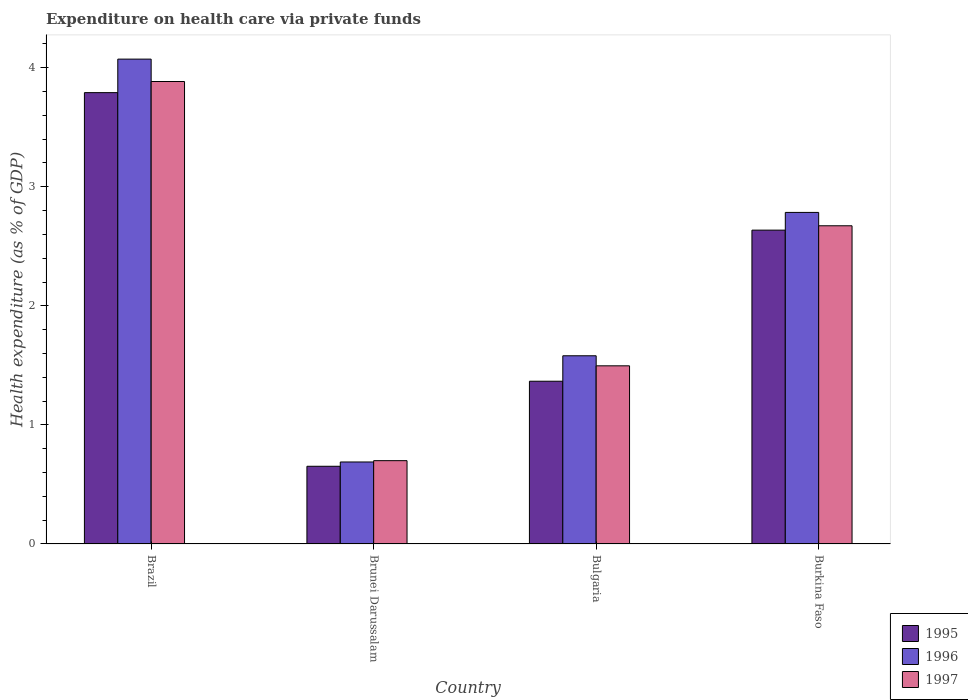How many bars are there on the 1st tick from the left?
Give a very brief answer. 3. In how many cases, is the number of bars for a given country not equal to the number of legend labels?
Ensure brevity in your answer.  0. What is the expenditure made on health care in 1995 in Brazil?
Your answer should be very brief. 3.79. Across all countries, what is the maximum expenditure made on health care in 1997?
Your response must be concise. 3.88. Across all countries, what is the minimum expenditure made on health care in 1996?
Ensure brevity in your answer.  0.69. In which country was the expenditure made on health care in 1996 minimum?
Your response must be concise. Brunei Darussalam. What is the total expenditure made on health care in 1995 in the graph?
Provide a short and direct response. 8.45. What is the difference between the expenditure made on health care in 1996 in Brunei Darussalam and that in Burkina Faso?
Make the answer very short. -2.1. What is the difference between the expenditure made on health care in 1997 in Burkina Faso and the expenditure made on health care in 1996 in Brunei Darussalam?
Ensure brevity in your answer.  1.98. What is the average expenditure made on health care in 1996 per country?
Make the answer very short. 2.28. What is the difference between the expenditure made on health care of/in 1997 and expenditure made on health care of/in 1996 in Bulgaria?
Offer a very short reply. -0.08. What is the ratio of the expenditure made on health care in 1997 in Brunei Darussalam to that in Burkina Faso?
Your response must be concise. 0.26. Is the expenditure made on health care in 1995 in Brazil less than that in Bulgaria?
Your answer should be very brief. No. Is the difference between the expenditure made on health care in 1997 in Brazil and Bulgaria greater than the difference between the expenditure made on health care in 1996 in Brazil and Bulgaria?
Offer a terse response. No. What is the difference between the highest and the second highest expenditure made on health care in 1996?
Ensure brevity in your answer.  -1.2. What is the difference between the highest and the lowest expenditure made on health care in 1995?
Offer a very short reply. 3.14. In how many countries, is the expenditure made on health care in 1996 greater than the average expenditure made on health care in 1996 taken over all countries?
Ensure brevity in your answer.  2. Is the sum of the expenditure made on health care in 1996 in Brunei Darussalam and Burkina Faso greater than the maximum expenditure made on health care in 1995 across all countries?
Ensure brevity in your answer.  No. How many bars are there?
Your response must be concise. 12. Are all the bars in the graph horizontal?
Ensure brevity in your answer.  No. How many countries are there in the graph?
Your response must be concise. 4. What is the difference between two consecutive major ticks on the Y-axis?
Make the answer very short. 1. What is the title of the graph?
Make the answer very short. Expenditure on health care via private funds. What is the label or title of the X-axis?
Your response must be concise. Country. What is the label or title of the Y-axis?
Keep it short and to the point. Health expenditure (as % of GDP). What is the Health expenditure (as % of GDP) of 1995 in Brazil?
Keep it short and to the point. 3.79. What is the Health expenditure (as % of GDP) of 1996 in Brazil?
Provide a succinct answer. 4.07. What is the Health expenditure (as % of GDP) in 1997 in Brazil?
Provide a short and direct response. 3.88. What is the Health expenditure (as % of GDP) of 1995 in Brunei Darussalam?
Provide a short and direct response. 0.65. What is the Health expenditure (as % of GDP) of 1996 in Brunei Darussalam?
Provide a succinct answer. 0.69. What is the Health expenditure (as % of GDP) in 1997 in Brunei Darussalam?
Ensure brevity in your answer.  0.7. What is the Health expenditure (as % of GDP) in 1995 in Bulgaria?
Give a very brief answer. 1.37. What is the Health expenditure (as % of GDP) in 1996 in Bulgaria?
Provide a short and direct response. 1.58. What is the Health expenditure (as % of GDP) of 1997 in Bulgaria?
Your answer should be very brief. 1.5. What is the Health expenditure (as % of GDP) of 1995 in Burkina Faso?
Offer a terse response. 2.64. What is the Health expenditure (as % of GDP) in 1996 in Burkina Faso?
Make the answer very short. 2.78. What is the Health expenditure (as % of GDP) in 1997 in Burkina Faso?
Make the answer very short. 2.67. Across all countries, what is the maximum Health expenditure (as % of GDP) in 1995?
Your answer should be compact. 3.79. Across all countries, what is the maximum Health expenditure (as % of GDP) in 1996?
Provide a short and direct response. 4.07. Across all countries, what is the maximum Health expenditure (as % of GDP) of 1997?
Offer a terse response. 3.88. Across all countries, what is the minimum Health expenditure (as % of GDP) in 1995?
Provide a succinct answer. 0.65. Across all countries, what is the minimum Health expenditure (as % of GDP) of 1996?
Make the answer very short. 0.69. Across all countries, what is the minimum Health expenditure (as % of GDP) in 1997?
Your answer should be compact. 0.7. What is the total Health expenditure (as % of GDP) of 1995 in the graph?
Provide a short and direct response. 8.45. What is the total Health expenditure (as % of GDP) in 1996 in the graph?
Make the answer very short. 9.13. What is the total Health expenditure (as % of GDP) in 1997 in the graph?
Give a very brief answer. 8.75. What is the difference between the Health expenditure (as % of GDP) in 1995 in Brazil and that in Brunei Darussalam?
Keep it short and to the point. 3.14. What is the difference between the Health expenditure (as % of GDP) of 1996 in Brazil and that in Brunei Darussalam?
Keep it short and to the point. 3.38. What is the difference between the Health expenditure (as % of GDP) of 1997 in Brazil and that in Brunei Darussalam?
Your answer should be very brief. 3.18. What is the difference between the Health expenditure (as % of GDP) of 1995 in Brazil and that in Bulgaria?
Offer a terse response. 2.42. What is the difference between the Health expenditure (as % of GDP) of 1996 in Brazil and that in Bulgaria?
Ensure brevity in your answer.  2.49. What is the difference between the Health expenditure (as % of GDP) of 1997 in Brazil and that in Bulgaria?
Keep it short and to the point. 2.39. What is the difference between the Health expenditure (as % of GDP) in 1995 in Brazil and that in Burkina Faso?
Give a very brief answer. 1.15. What is the difference between the Health expenditure (as % of GDP) in 1996 in Brazil and that in Burkina Faso?
Your answer should be compact. 1.29. What is the difference between the Health expenditure (as % of GDP) of 1997 in Brazil and that in Burkina Faso?
Offer a very short reply. 1.21. What is the difference between the Health expenditure (as % of GDP) of 1995 in Brunei Darussalam and that in Bulgaria?
Give a very brief answer. -0.71. What is the difference between the Health expenditure (as % of GDP) of 1996 in Brunei Darussalam and that in Bulgaria?
Offer a terse response. -0.89. What is the difference between the Health expenditure (as % of GDP) of 1997 in Brunei Darussalam and that in Bulgaria?
Offer a terse response. -0.8. What is the difference between the Health expenditure (as % of GDP) in 1995 in Brunei Darussalam and that in Burkina Faso?
Keep it short and to the point. -1.98. What is the difference between the Health expenditure (as % of GDP) of 1996 in Brunei Darussalam and that in Burkina Faso?
Your answer should be very brief. -2.1. What is the difference between the Health expenditure (as % of GDP) in 1997 in Brunei Darussalam and that in Burkina Faso?
Your response must be concise. -1.97. What is the difference between the Health expenditure (as % of GDP) in 1995 in Bulgaria and that in Burkina Faso?
Your response must be concise. -1.27. What is the difference between the Health expenditure (as % of GDP) in 1996 in Bulgaria and that in Burkina Faso?
Offer a very short reply. -1.2. What is the difference between the Health expenditure (as % of GDP) of 1997 in Bulgaria and that in Burkina Faso?
Offer a terse response. -1.18. What is the difference between the Health expenditure (as % of GDP) in 1995 in Brazil and the Health expenditure (as % of GDP) in 1996 in Brunei Darussalam?
Provide a short and direct response. 3.1. What is the difference between the Health expenditure (as % of GDP) in 1995 in Brazil and the Health expenditure (as % of GDP) in 1997 in Brunei Darussalam?
Your response must be concise. 3.09. What is the difference between the Health expenditure (as % of GDP) in 1996 in Brazil and the Health expenditure (as % of GDP) in 1997 in Brunei Darussalam?
Your answer should be very brief. 3.37. What is the difference between the Health expenditure (as % of GDP) in 1995 in Brazil and the Health expenditure (as % of GDP) in 1996 in Bulgaria?
Your answer should be very brief. 2.21. What is the difference between the Health expenditure (as % of GDP) in 1995 in Brazil and the Health expenditure (as % of GDP) in 1997 in Bulgaria?
Ensure brevity in your answer.  2.29. What is the difference between the Health expenditure (as % of GDP) of 1996 in Brazil and the Health expenditure (as % of GDP) of 1997 in Bulgaria?
Offer a very short reply. 2.58. What is the difference between the Health expenditure (as % of GDP) of 1995 in Brazil and the Health expenditure (as % of GDP) of 1996 in Burkina Faso?
Offer a very short reply. 1.01. What is the difference between the Health expenditure (as % of GDP) in 1995 in Brazil and the Health expenditure (as % of GDP) in 1997 in Burkina Faso?
Your response must be concise. 1.12. What is the difference between the Health expenditure (as % of GDP) in 1996 in Brazil and the Health expenditure (as % of GDP) in 1997 in Burkina Faso?
Keep it short and to the point. 1.4. What is the difference between the Health expenditure (as % of GDP) of 1995 in Brunei Darussalam and the Health expenditure (as % of GDP) of 1996 in Bulgaria?
Your answer should be compact. -0.93. What is the difference between the Health expenditure (as % of GDP) in 1995 in Brunei Darussalam and the Health expenditure (as % of GDP) in 1997 in Bulgaria?
Make the answer very short. -0.84. What is the difference between the Health expenditure (as % of GDP) in 1996 in Brunei Darussalam and the Health expenditure (as % of GDP) in 1997 in Bulgaria?
Keep it short and to the point. -0.81. What is the difference between the Health expenditure (as % of GDP) of 1995 in Brunei Darussalam and the Health expenditure (as % of GDP) of 1996 in Burkina Faso?
Ensure brevity in your answer.  -2.13. What is the difference between the Health expenditure (as % of GDP) of 1995 in Brunei Darussalam and the Health expenditure (as % of GDP) of 1997 in Burkina Faso?
Provide a succinct answer. -2.02. What is the difference between the Health expenditure (as % of GDP) in 1996 in Brunei Darussalam and the Health expenditure (as % of GDP) in 1997 in Burkina Faso?
Your answer should be compact. -1.98. What is the difference between the Health expenditure (as % of GDP) in 1995 in Bulgaria and the Health expenditure (as % of GDP) in 1996 in Burkina Faso?
Your answer should be very brief. -1.42. What is the difference between the Health expenditure (as % of GDP) of 1995 in Bulgaria and the Health expenditure (as % of GDP) of 1997 in Burkina Faso?
Give a very brief answer. -1.31. What is the difference between the Health expenditure (as % of GDP) in 1996 in Bulgaria and the Health expenditure (as % of GDP) in 1997 in Burkina Faso?
Offer a terse response. -1.09. What is the average Health expenditure (as % of GDP) of 1995 per country?
Provide a short and direct response. 2.11. What is the average Health expenditure (as % of GDP) of 1996 per country?
Keep it short and to the point. 2.28. What is the average Health expenditure (as % of GDP) in 1997 per country?
Ensure brevity in your answer.  2.19. What is the difference between the Health expenditure (as % of GDP) in 1995 and Health expenditure (as % of GDP) in 1996 in Brazil?
Give a very brief answer. -0.28. What is the difference between the Health expenditure (as % of GDP) in 1995 and Health expenditure (as % of GDP) in 1997 in Brazil?
Provide a short and direct response. -0.09. What is the difference between the Health expenditure (as % of GDP) of 1996 and Health expenditure (as % of GDP) of 1997 in Brazil?
Make the answer very short. 0.19. What is the difference between the Health expenditure (as % of GDP) in 1995 and Health expenditure (as % of GDP) in 1996 in Brunei Darussalam?
Provide a short and direct response. -0.04. What is the difference between the Health expenditure (as % of GDP) in 1995 and Health expenditure (as % of GDP) in 1997 in Brunei Darussalam?
Your answer should be compact. -0.05. What is the difference between the Health expenditure (as % of GDP) in 1996 and Health expenditure (as % of GDP) in 1997 in Brunei Darussalam?
Provide a succinct answer. -0.01. What is the difference between the Health expenditure (as % of GDP) in 1995 and Health expenditure (as % of GDP) in 1996 in Bulgaria?
Ensure brevity in your answer.  -0.21. What is the difference between the Health expenditure (as % of GDP) of 1995 and Health expenditure (as % of GDP) of 1997 in Bulgaria?
Your answer should be very brief. -0.13. What is the difference between the Health expenditure (as % of GDP) in 1996 and Health expenditure (as % of GDP) in 1997 in Bulgaria?
Ensure brevity in your answer.  0.08. What is the difference between the Health expenditure (as % of GDP) in 1995 and Health expenditure (as % of GDP) in 1996 in Burkina Faso?
Provide a short and direct response. -0.15. What is the difference between the Health expenditure (as % of GDP) in 1995 and Health expenditure (as % of GDP) in 1997 in Burkina Faso?
Ensure brevity in your answer.  -0.04. What is the difference between the Health expenditure (as % of GDP) in 1996 and Health expenditure (as % of GDP) in 1997 in Burkina Faso?
Give a very brief answer. 0.11. What is the ratio of the Health expenditure (as % of GDP) in 1995 in Brazil to that in Brunei Darussalam?
Offer a very short reply. 5.81. What is the ratio of the Health expenditure (as % of GDP) of 1996 in Brazil to that in Brunei Darussalam?
Your answer should be very brief. 5.91. What is the ratio of the Health expenditure (as % of GDP) in 1997 in Brazil to that in Brunei Darussalam?
Provide a short and direct response. 5.55. What is the ratio of the Health expenditure (as % of GDP) of 1995 in Brazil to that in Bulgaria?
Make the answer very short. 2.77. What is the ratio of the Health expenditure (as % of GDP) in 1996 in Brazil to that in Bulgaria?
Keep it short and to the point. 2.58. What is the ratio of the Health expenditure (as % of GDP) of 1997 in Brazil to that in Bulgaria?
Your response must be concise. 2.6. What is the ratio of the Health expenditure (as % of GDP) of 1995 in Brazil to that in Burkina Faso?
Make the answer very short. 1.44. What is the ratio of the Health expenditure (as % of GDP) in 1996 in Brazil to that in Burkina Faso?
Offer a terse response. 1.46. What is the ratio of the Health expenditure (as % of GDP) of 1997 in Brazil to that in Burkina Faso?
Offer a terse response. 1.45. What is the ratio of the Health expenditure (as % of GDP) of 1995 in Brunei Darussalam to that in Bulgaria?
Your answer should be compact. 0.48. What is the ratio of the Health expenditure (as % of GDP) of 1996 in Brunei Darussalam to that in Bulgaria?
Your answer should be very brief. 0.44. What is the ratio of the Health expenditure (as % of GDP) in 1997 in Brunei Darussalam to that in Bulgaria?
Give a very brief answer. 0.47. What is the ratio of the Health expenditure (as % of GDP) in 1995 in Brunei Darussalam to that in Burkina Faso?
Your response must be concise. 0.25. What is the ratio of the Health expenditure (as % of GDP) of 1996 in Brunei Darussalam to that in Burkina Faso?
Keep it short and to the point. 0.25. What is the ratio of the Health expenditure (as % of GDP) in 1997 in Brunei Darussalam to that in Burkina Faso?
Offer a terse response. 0.26. What is the ratio of the Health expenditure (as % of GDP) in 1995 in Bulgaria to that in Burkina Faso?
Your answer should be compact. 0.52. What is the ratio of the Health expenditure (as % of GDP) in 1996 in Bulgaria to that in Burkina Faso?
Your answer should be compact. 0.57. What is the ratio of the Health expenditure (as % of GDP) of 1997 in Bulgaria to that in Burkina Faso?
Your answer should be very brief. 0.56. What is the difference between the highest and the second highest Health expenditure (as % of GDP) of 1995?
Your response must be concise. 1.15. What is the difference between the highest and the second highest Health expenditure (as % of GDP) of 1996?
Provide a succinct answer. 1.29. What is the difference between the highest and the second highest Health expenditure (as % of GDP) in 1997?
Your answer should be very brief. 1.21. What is the difference between the highest and the lowest Health expenditure (as % of GDP) in 1995?
Your response must be concise. 3.14. What is the difference between the highest and the lowest Health expenditure (as % of GDP) of 1996?
Your response must be concise. 3.38. What is the difference between the highest and the lowest Health expenditure (as % of GDP) in 1997?
Ensure brevity in your answer.  3.18. 